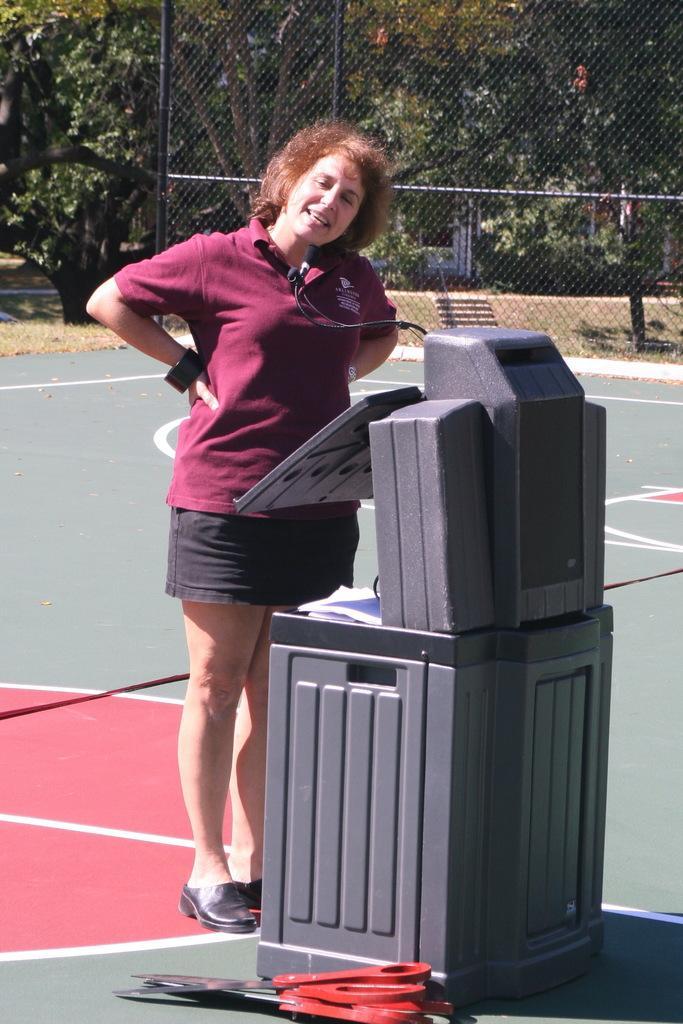Please provide a concise description of this image. In this picture we can see a woman standing on the ground, scissors and in the background we can see fence and trees. 